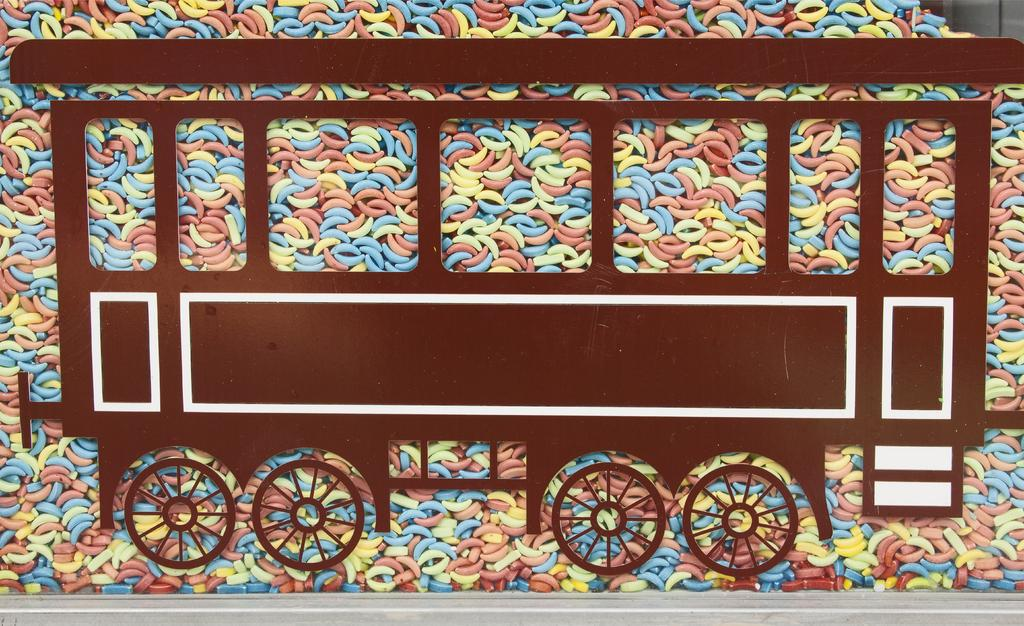What type of toy is present in the image? There is a toy vehicle in the image. What color is the toy vehicle? The toy vehicle is brown in color. What colors can be seen in the background of the image? The background of the image includes peach, blue, and yellow colors. What type of apparel is the toy vehicle wearing in the image? There is no apparel present in the image, as the subject is a toy vehicle and not a person or living being. 